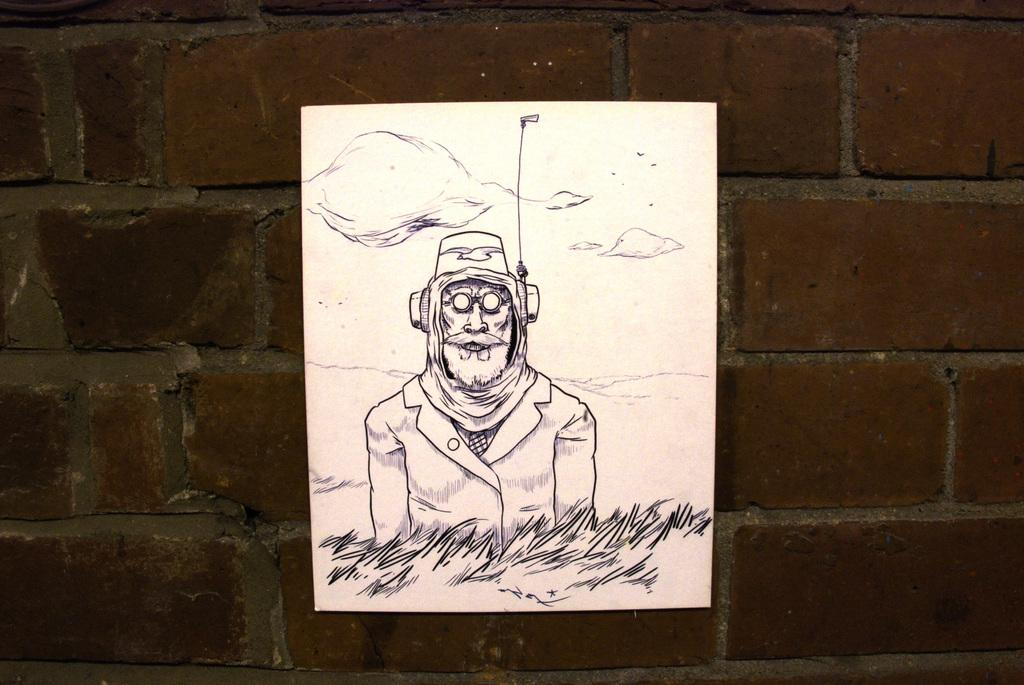What is present on the brick wall in the image? There is a paper attached to the brick wall in the image. What is depicted on the paper? A: There is a sketch of a person on the paper. How many ladybugs can be seen crawling on the toys in the image? There are no ladybugs or toys present in the image; it only features a paper with a sketch of a person on a brick wall. 